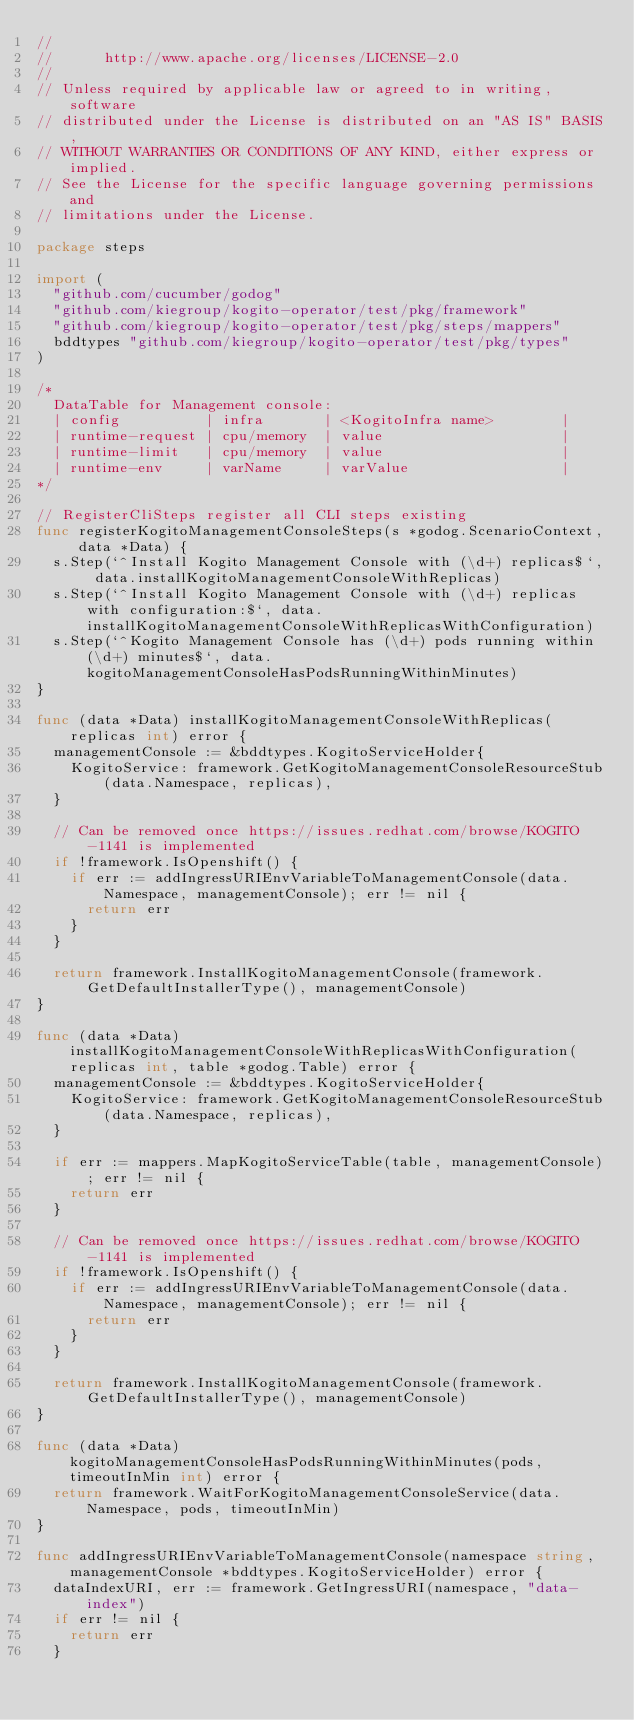<code> <loc_0><loc_0><loc_500><loc_500><_Go_>//
//      http://www.apache.org/licenses/LICENSE-2.0
//
// Unless required by applicable law or agreed to in writing, software
// distributed under the License is distributed on an "AS IS" BASIS,
// WITHOUT WARRANTIES OR CONDITIONS OF ANY KIND, either express or implied.
// See the License for the specific language governing permissions and
// limitations under the License.

package steps

import (
	"github.com/cucumber/godog"
	"github.com/kiegroup/kogito-operator/test/pkg/framework"
	"github.com/kiegroup/kogito-operator/test/pkg/steps/mappers"
	bddtypes "github.com/kiegroup/kogito-operator/test/pkg/types"
)

/*
	DataTable for Management console:
	| config          | infra       | <KogitoInfra name>        |
	| runtime-request | cpu/memory  | value                     |
	| runtime-limit   | cpu/memory  | value                     |
	| runtime-env     | varName     | varValue                  |
*/

// RegisterCliSteps register all CLI steps existing
func registerKogitoManagementConsoleSteps(s *godog.ScenarioContext, data *Data) {
	s.Step(`^Install Kogito Management Console with (\d+) replicas$`, data.installKogitoManagementConsoleWithReplicas)
	s.Step(`^Install Kogito Management Console with (\d+) replicas with configuration:$`, data.installKogitoManagementConsoleWithReplicasWithConfiguration)
	s.Step(`^Kogito Management Console has (\d+) pods running within (\d+) minutes$`, data.kogitoManagementConsoleHasPodsRunningWithinMinutes)
}

func (data *Data) installKogitoManagementConsoleWithReplicas(replicas int) error {
	managementConsole := &bddtypes.KogitoServiceHolder{
		KogitoService: framework.GetKogitoManagementConsoleResourceStub(data.Namespace, replicas),
	}

	// Can be removed once https://issues.redhat.com/browse/KOGITO-1141 is implemented
	if !framework.IsOpenshift() {
		if err := addIngressURIEnvVariableToManagementConsole(data.Namespace, managementConsole); err != nil {
			return err
		}
	}

	return framework.InstallKogitoManagementConsole(framework.GetDefaultInstallerType(), managementConsole)
}

func (data *Data) installKogitoManagementConsoleWithReplicasWithConfiguration(replicas int, table *godog.Table) error {
	managementConsole := &bddtypes.KogitoServiceHolder{
		KogitoService: framework.GetKogitoManagementConsoleResourceStub(data.Namespace, replicas),
	}

	if err := mappers.MapKogitoServiceTable(table, managementConsole); err != nil {
		return err
	}

	// Can be removed once https://issues.redhat.com/browse/KOGITO-1141 is implemented
	if !framework.IsOpenshift() {
		if err := addIngressURIEnvVariableToManagementConsole(data.Namespace, managementConsole); err != nil {
			return err
		}
	}

	return framework.InstallKogitoManagementConsole(framework.GetDefaultInstallerType(), managementConsole)
}

func (data *Data) kogitoManagementConsoleHasPodsRunningWithinMinutes(pods, timeoutInMin int) error {
	return framework.WaitForKogitoManagementConsoleService(data.Namespace, pods, timeoutInMin)
}

func addIngressURIEnvVariableToManagementConsole(namespace string, managementConsole *bddtypes.KogitoServiceHolder) error {
	dataIndexURI, err := framework.GetIngressURI(namespace, "data-index")
	if err != nil {
		return err
	}</code> 